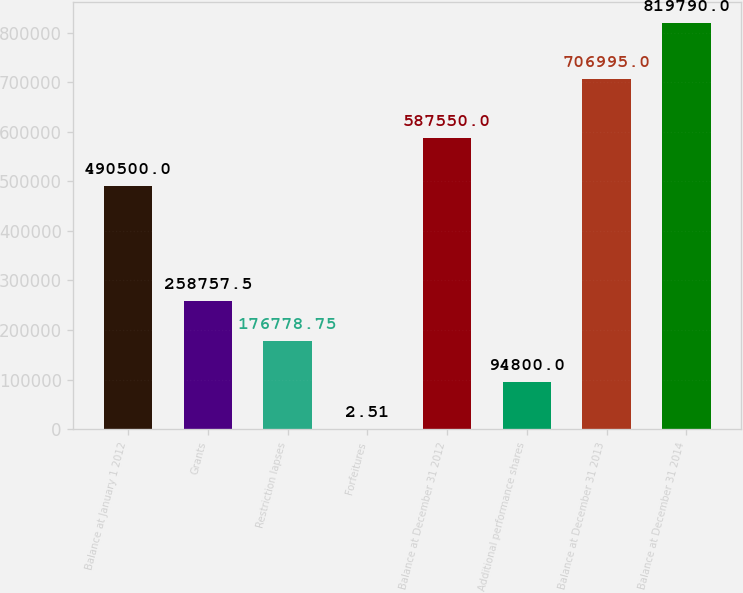Convert chart. <chart><loc_0><loc_0><loc_500><loc_500><bar_chart><fcel>Balance at January 1 2012<fcel>Grants<fcel>Restriction lapses<fcel>Forfeitures<fcel>Balance at December 31 2012<fcel>Additional performance shares<fcel>Balance at December 31 2013<fcel>Balance at December 31 2014<nl><fcel>490500<fcel>258758<fcel>176779<fcel>2.51<fcel>587550<fcel>94800<fcel>706995<fcel>819790<nl></chart> 